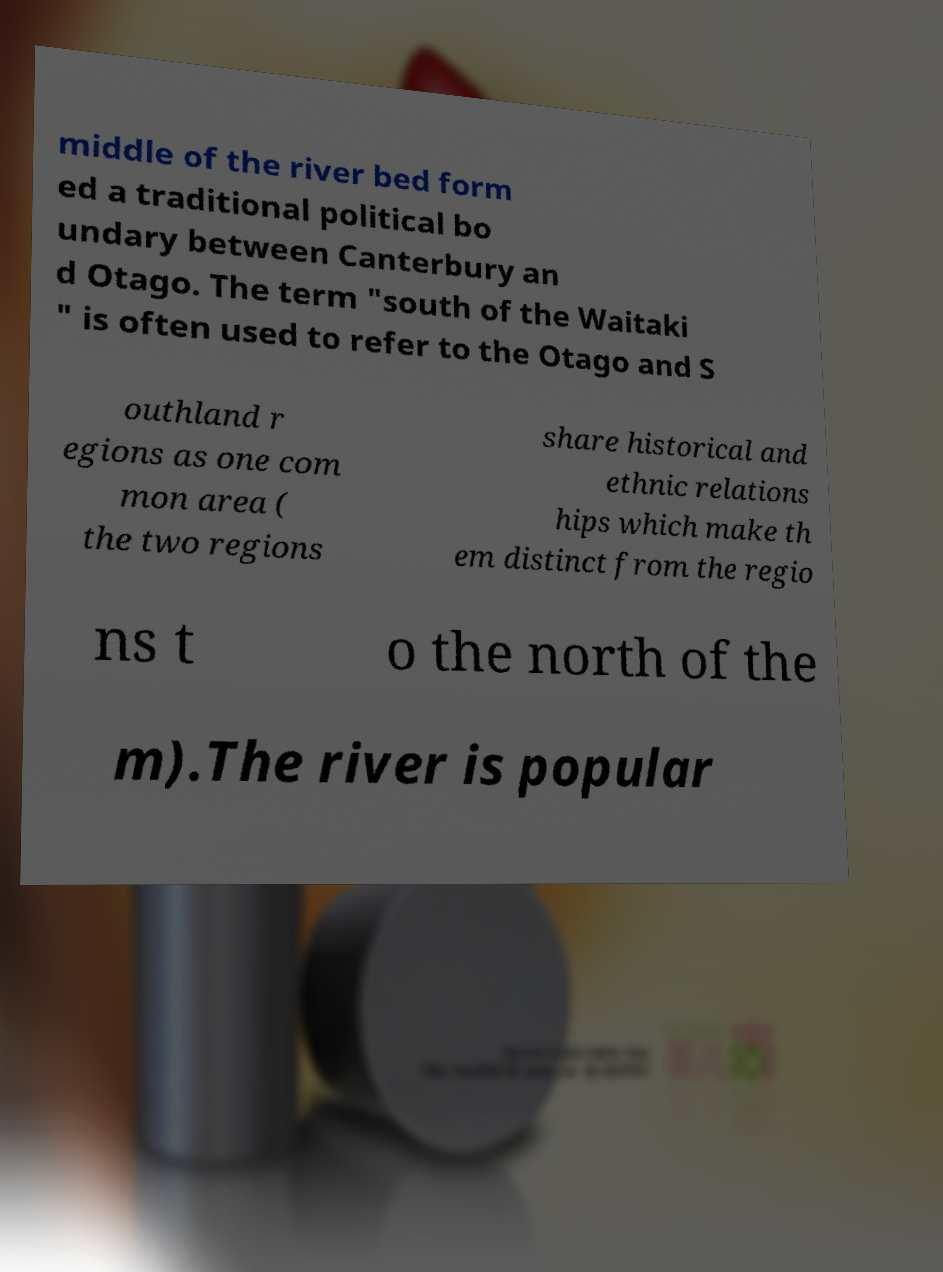Can you read and provide the text displayed in the image?This photo seems to have some interesting text. Can you extract and type it out for me? middle of the river bed form ed a traditional political bo undary between Canterbury an d Otago. The term "south of the Waitaki " is often used to refer to the Otago and S outhland r egions as one com mon area ( the two regions share historical and ethnic relations hips which make th em distinct from the regio ns t o the north of the m).The river is popular 